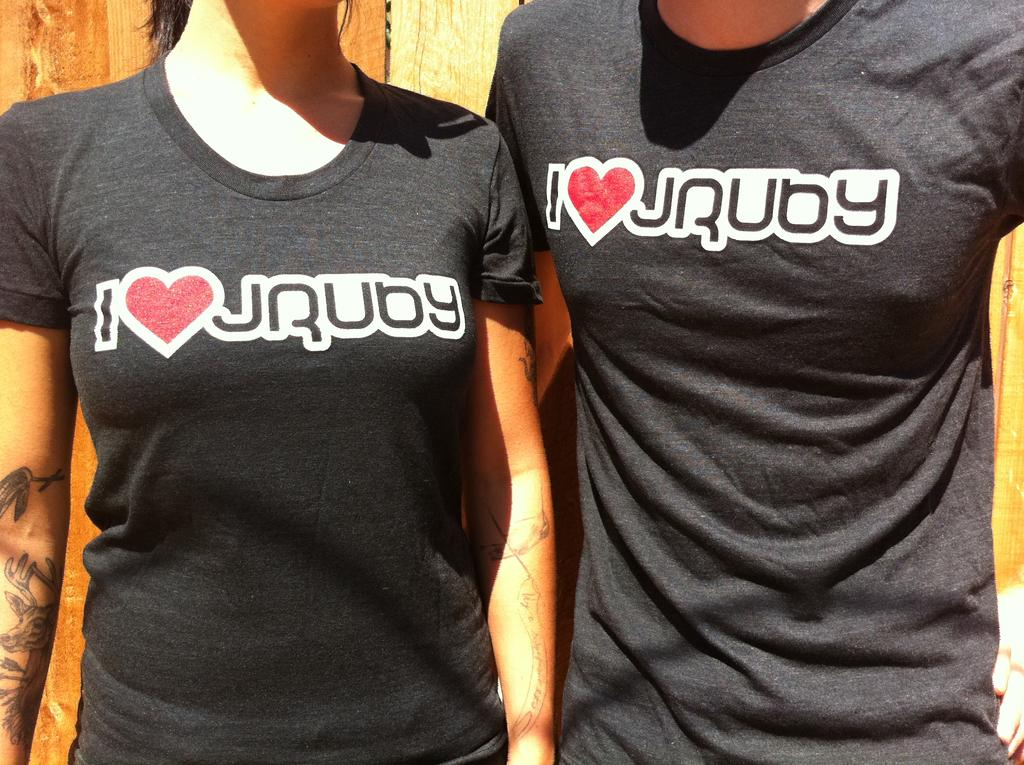<image>
Offer a succinct explanation of the picture presented. man and woman wearing black tshirts with i heart jruby on them 